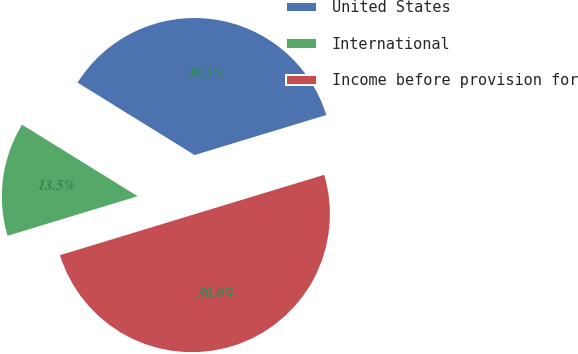Convert chart. <chart><loc_0><loc_0><loc_500><loc_500><pie_chart><fcel>United States<fcel>International<fcel>Income before provision for<nl><fcel>36.48%<fcel>13.52%<fcel>50.0%<nl></chart> 